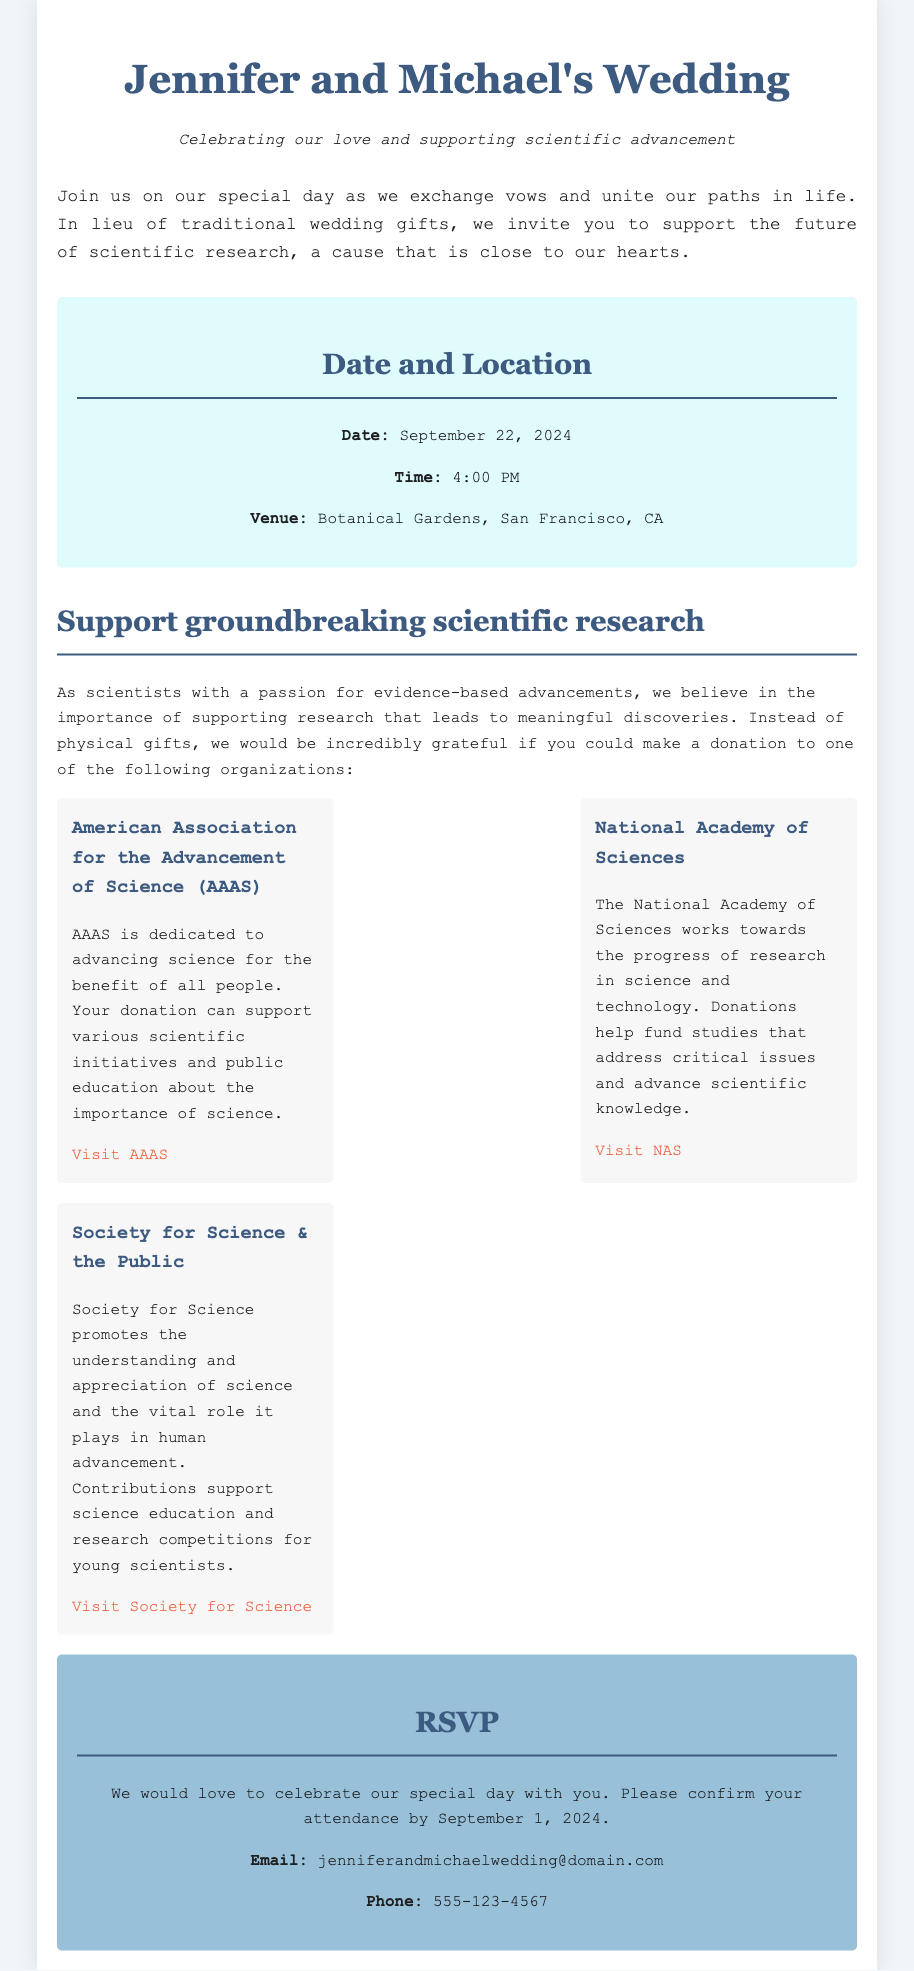What is the date of the wedding? The date is explicitly mentioned in the "Date and Location" section of the document.
Answer: September 22, 2024 What time does the wedding ceremony start? The time is provided in the same section, indicating when the event occurs.
Answer: 4:00 PM What venue will the wedding take place? The venue is stated clearly in the "Date and Location" section where the location details are given.
Answer: Botanical Gardens, San Francisco, CA What is the main purpose of the wedding invitation? The main message informs attendees of what the couple desires instead of traditional gifts.
Answer: Supporting scientific research How many organizations are listed for donations? The number can be counted by looking at the list of organizations provided in the invitation.
Answer: Three What is the email address for RSVPs? The email is given in the RSVP section to confirm attendance at the wedding.
Answer: jenniferandmichaelwedding@domain.com Which organization focuses on science education and competitions? The relevant organization is highlighted in the description about contributions supporting education.
Answer: Society for Science & the Public What is the significance of supporting scientific research for the couple? The couple expresses their passion and belief in the importance of funding scientific advancements.
Answer: Evidence-based advancements When is the deadline for RSVPs? The deadline is stated within the RSVP section for attending the wedding celebration.
Answer: September 1, 2024 